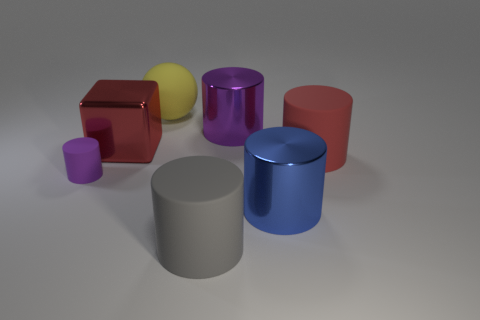Add 2 large metallic cubes. How many objects exist? 9 Subtract all large red cylinders. How many cylinders are left? 4 Subtract all purple cylinders. How many cylinders are left? 3 Subtract all cubes. How many objects are left? 6 Subtract 3 cylinders. How many cylinders are left? 2 Subtract all yellow cylinders. How many blue blocks are left? 0 Subtract all large blue metal cubes. Subtract all big purple metal cylinders. How many objects are left? 6 Add 5 blue shiny cylinders. How many blue shiny cylinders are left? 6 Add 7 brown shiny balls. How many brown shiny balls exist? 7 Subtract 1 yellow spheres. How many objects are left? 6 